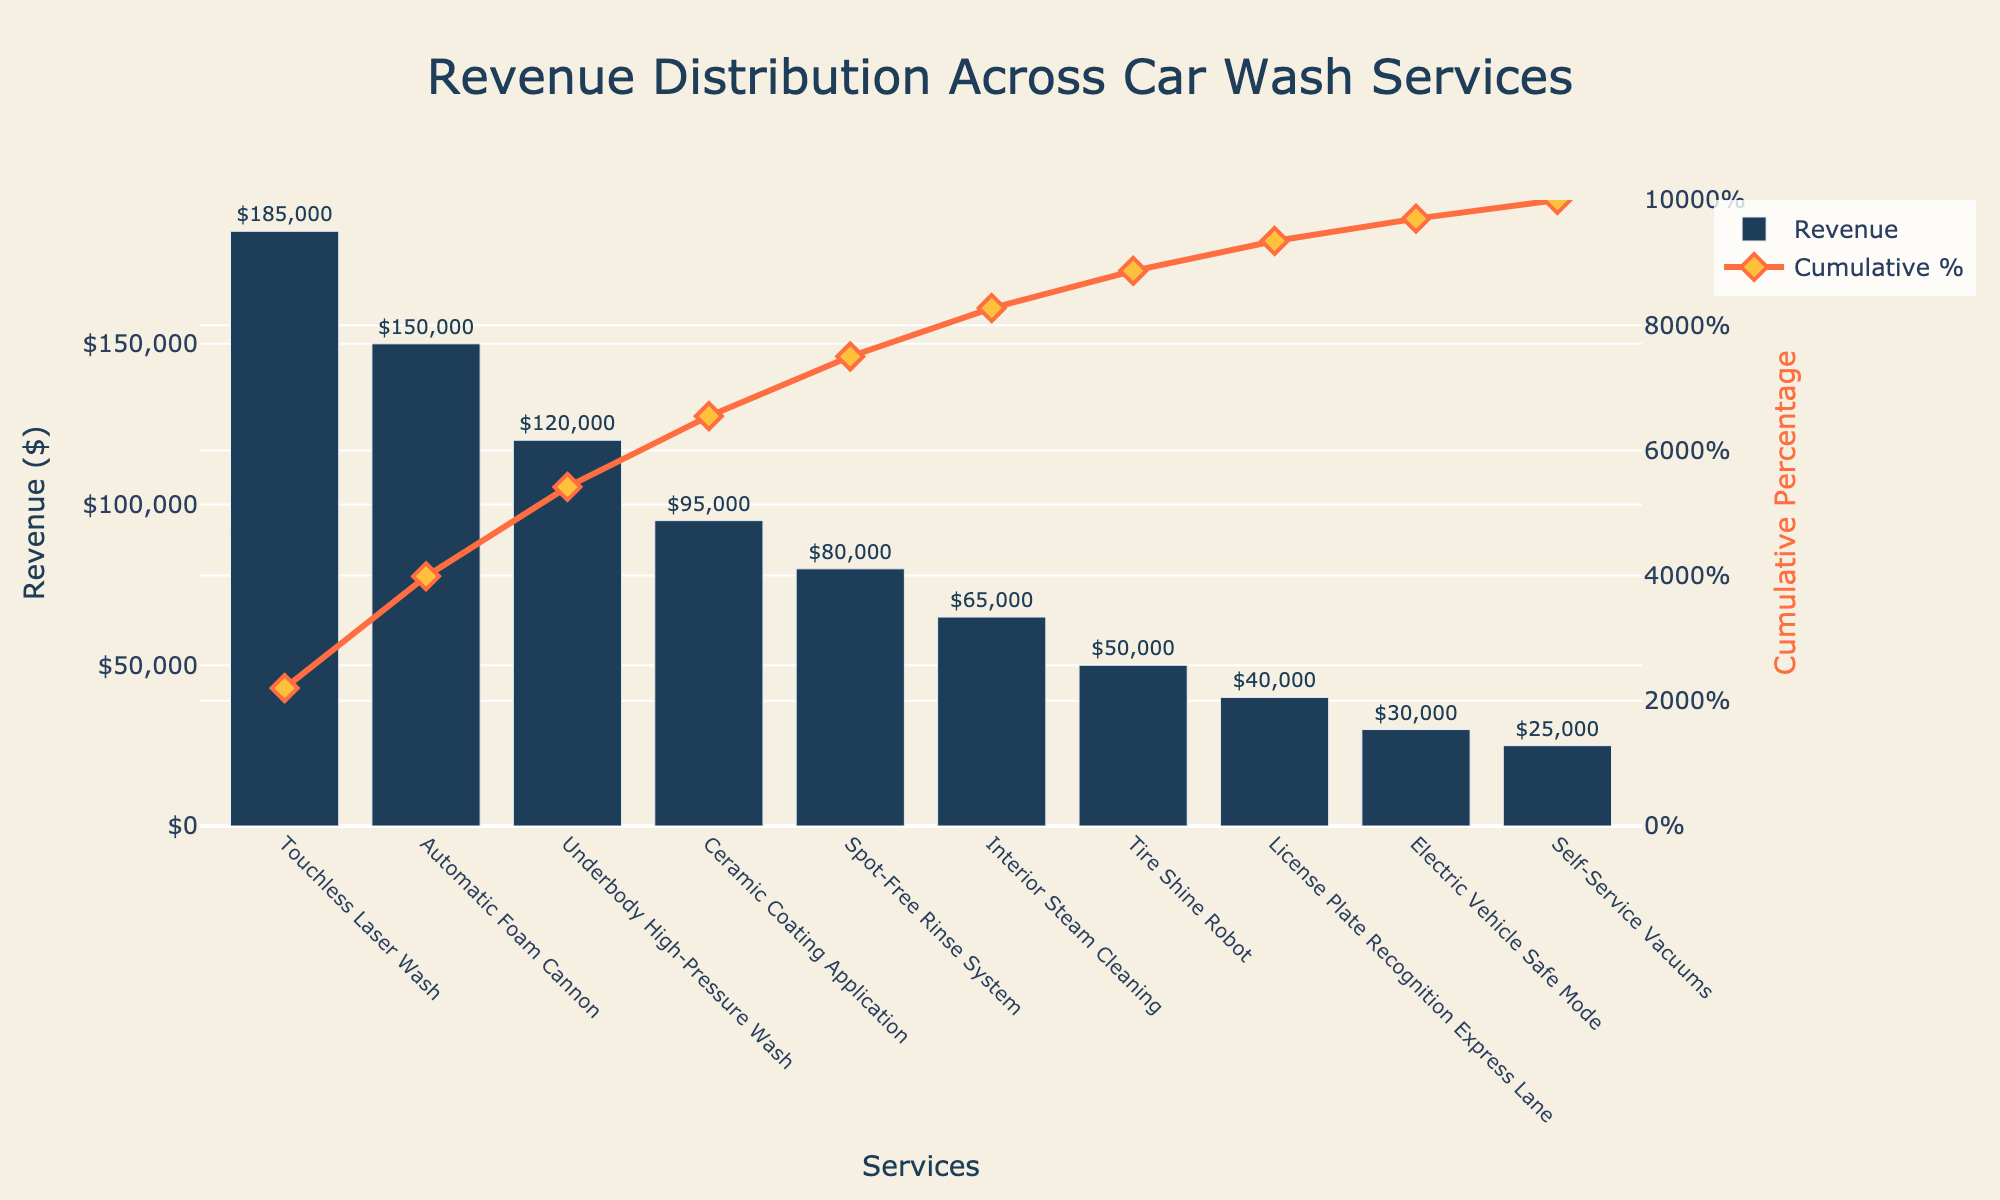What is the title of the figure? The title is usually placed at the top of the chart. Here, it reads "Revenue Distribution Across Car Wash Services".
Answer: Revenue Distribution Across Car Wash Services How many car wash services are listed in the chart? Counting the bars in the bar chart will give the number of car wash services.
Answer: 10 Which car wash service generates the highest revenue? The car wash service with the tallest bar represents the highest revenue.
Answer: Touchless Laser Wash What is the cumulative percentage of revenue at the third service in the list? The third service in the sorted list is "Underbody High-Pressure Wash". Look at its cumulative percentage in the line chart.
Answer: 53.4% What is the difference in revenue between the highest and lowest service? Subtract the revenue of the lowest service from the highest service. $185,000 (Touchless Laser Wash) - $25,000 (Self-Service Vacuums) = $160,000
Answer: $160,000 Which service marks the 50% cumulative percentage point? Find the first service in the line chart where the cumulative percentage surpasses 50%. This occurs around the "Underbody High-Pressure Wash" service.
Answer: Underbody High-Pressure Wash What percentage of the total revenue is contributed by the top two services? Add the revenues of the top two services and divide by the total revenue, then multiply by 100. [(185,000 + 150,000) / (185,000 + 150,000 + 120,000 + 95,000 + 80,000 + 65,000 + 50,000 + 40,000 + 30,000 + 25,000)] * 100 = 56%
Answer: 56% Which service has the smallest contribution to total revenue? The car wash service with the shortest bar represents the smallest revenue.
Answer: Self-Service Vacuums How much revenue is generated by the services that together make up approximately 80% of the cumulative percentage? Identify the services until the cumulative percentage line is just above 80%. Summing revenues of "Touchless Laser Wash", "Automatic Foam Cannon", "Underbody High-Pressure Wash", "Ceramic Coating Application", and "Spot-Free Rinse System" yields $185,000 + $150,000 + $120,000 + $95,000 + $80,000 = $630,000.
Answer: $630,000 If the combined revenue of "Interior Steam Cleaning" and "Tire Shine Robot" was displayed as a single bar, where would it likely fall in the sorted order? Adding the revenue of "Interior Steam Cleaning" ($65,000) and "Tire Shine Robot" ($50,000) gives $115,000. This combined value would be between "Underbody High-Pressure Wash" ($120,000) and "Ceramic Coating Application" ($95,000).
Answer: Between Underbody High-Pressure Wash and Ceramic Coating Application 